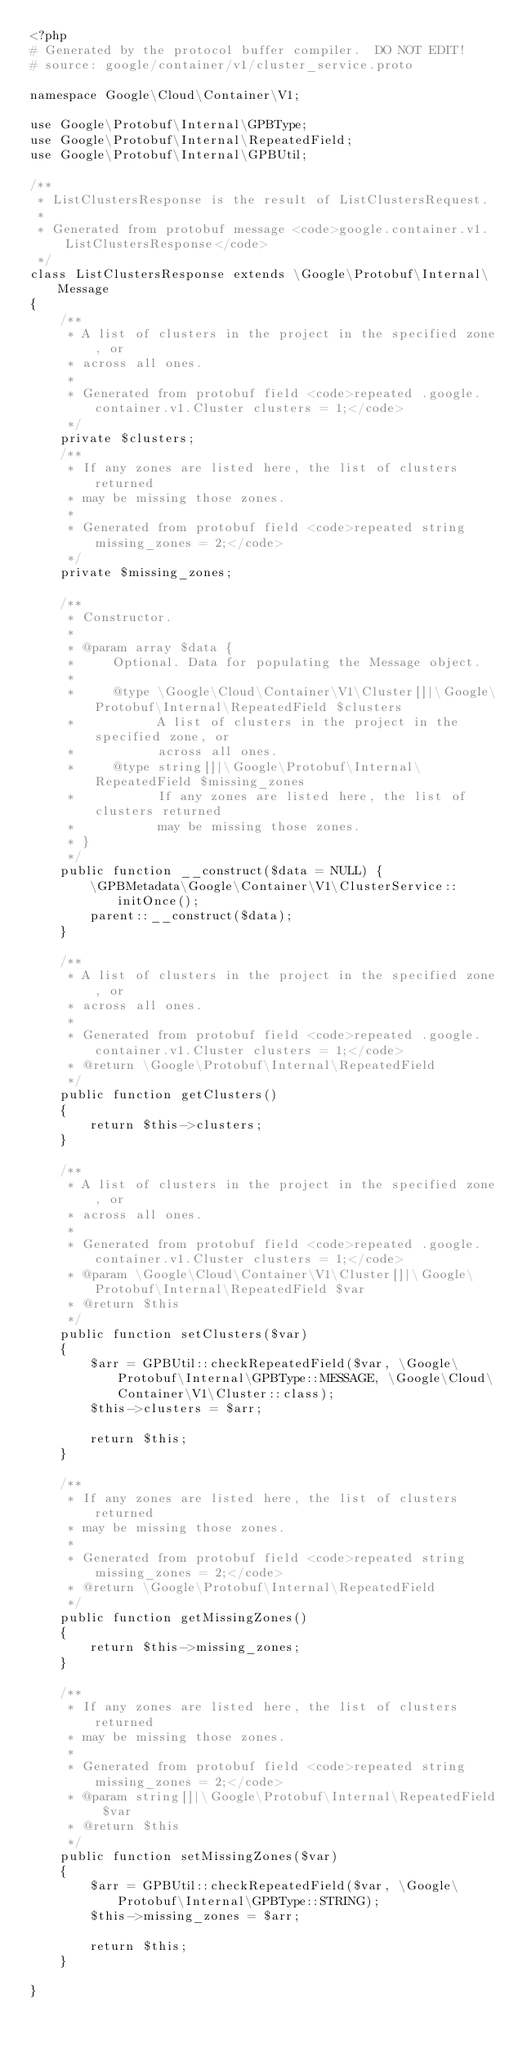<code> <loc_0><loc_0><loc_500><loc_500><_PHP_><?php
# Generated by the protocol buffer compiler.  DO NOT EDIT!
# source: google/container/v1/cluster_service.proto

namespace Google\Cloud\Container\V1;

use Google\Protobuf\Internal\GPBType;
use Google\Protobuf\Internal\RepeatedField;
use Google\Protobuf\Internal\GPBUtil;

/**
 * ListClustersResponse is the result of ListClustersRequest.
 *
 * Generated from protobuf message <code>google.container.v1.ListClustersResponse</code>
 */
class ListClustersResponse extends \Google\Protobuf\Internal\Message
{
    /**
     * A list of clusters in the project in the specified zone, or
     * across all ones.
     *
     * Generated from protobuf field <code>repeated .google.container.v1.Cluster clusters = 1;</code>
     */
    private $clusters;
    /**
     * If any zones are listed here, the list of clusters returned
     * may be missing those zones.
     *
     * Generated from protobuf field <code>repeated string missing_zones = 2;</code>
     */
    private $missing_zones;

    /**
     * Constructor.
     *
     * @param array $data {
     *     Optional. Data for populating the Message object.
     *
     *     @type \Google\Cloud\Container\V1\Cluster[]|\Google\Protobuf\Internal\RepeatedField $clusters
     *           A list of clusters in the project in the specified zone, or
     *           across all ones.
     *     @type string[]|\Google\Protobuf\Internal\RepeatedField $missing_zones
     *           If any zones are listed here, the list of clusters returned
     *           may be missing those zones.
     * }
     */
    public function __construct($data = NULL) {
        \GPBMetadata\Google\Container\V1\ClusterService::initOnce();
        parent::__construct($data);
    }

    /**
     * A list of clusters in the project in the specified zone, or
     * across all ones.
     *
     * Generated from protobuf field <code>repeated .google.container.v1.Cluster clusters = 1;</code>
     * @return \Google\Protobuf\Internal\RepeatedField
     */
    public function getClusters()
    {
        return $this->clusters;
    }

    /**
     * A list of clusters in the project in the specified zone, or
     * across all ones.
     *
     * Generated from protobuf field <code>repeated .google.container.v1.Cluster clusters = 1;</code>
     * @param \Google\Cloud\Container\V1\Cluster[]|\Google\Protobuf\Internal\RepeatedField $var
     * @return $this
     */
    public function setClusters($var)
    {
        $arr = GPBUtil::checkRepeatedField($var, \Google\Protobuf\Internal\GPBType::MESSAGE, \Google\Cloud\Container\V1\Cluster::class);
        $this->clusters = $arr;

        return $this;
    }

    /**
     * If any zones are listed here, the list of clusters returned
     * may be missing those zones.
     *
     * Generated from protobuf field <code>repeated string missing_zones = 2;</code>
     * @return \Google\Protobuf\Internal\RepeatedField
     */
    public function getMissingZones()
    {
        return $this->missing_zones;
    }

    /**
     * If any zones are listed here, the list of clusters returned
     * may be missing those zones.
     *
     * Generated from protobuf field <code>repeated string missing_zones = 2;</code>
     * @param string[]|\Google\Protobuf\Internal\RepeatedField $var
     * @return $this
     */
    public function setMissingZones($var)
    {
        $arr = GPBUtil::checkRepeatedField($var, \Google\Protobuf\Internal\GPBType::STRING);
        $this->missing_zones = $arr;

        return $this;
    }

}

</code> 